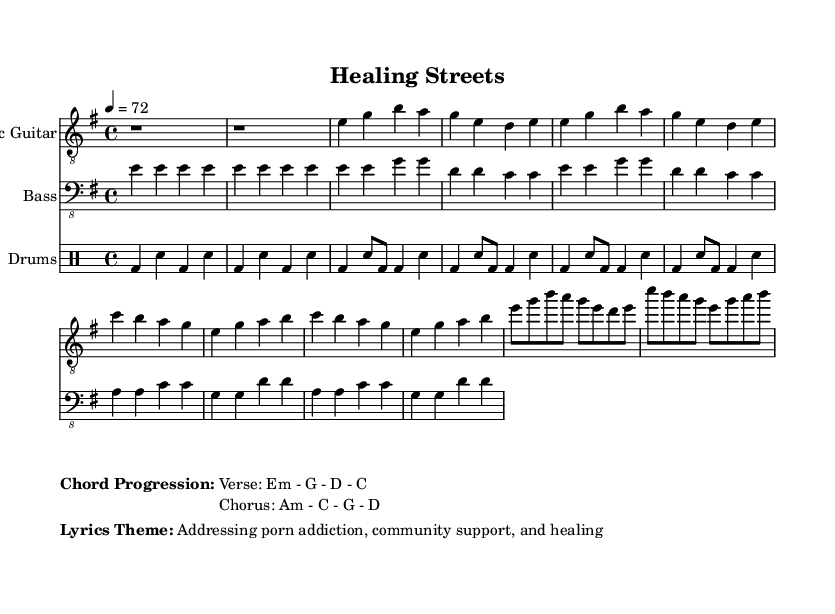What is the key signature of this music? The key signature is E minor, which has one sharp (F#) and indicates that the piece is primarily in the E minor scale.
Answer: E minor What is the time signature of this sheet music? The time signature is 4/4, indicating that there are four beats in each measure and the quarter note receives one beat.
Answer: 4/4 What is the tempo marking? The tempo marking is quarter note equals 72, suggesting a moderate pace for the performance of the music.
Answer: Quarter note equals 72 How many chords are in the verse progression? The verse progression contains four chords: E minor, G major, D major, and C major, as specified in the markup under the chord progression section.
Answer: Four What is the main theme of the lyrics? The main theme of the lyrics addresses porn addiction and community support, focusing on the healing aspects and social issues tied to the topic.
Answer: Addressing porn addiction, community support, healing What instruments are included in this score? The score includes electric guitar, bass, and drums, as seen in the titles for each staff in the sheet music.
Answer: Electric guitar, bass, drums What type of music does this sheet represent? This sheet represents Electric Blues, characterized by its use of electric instruments and a focus on gritty themes reflecting social issues.
Answer: Electric Blues 